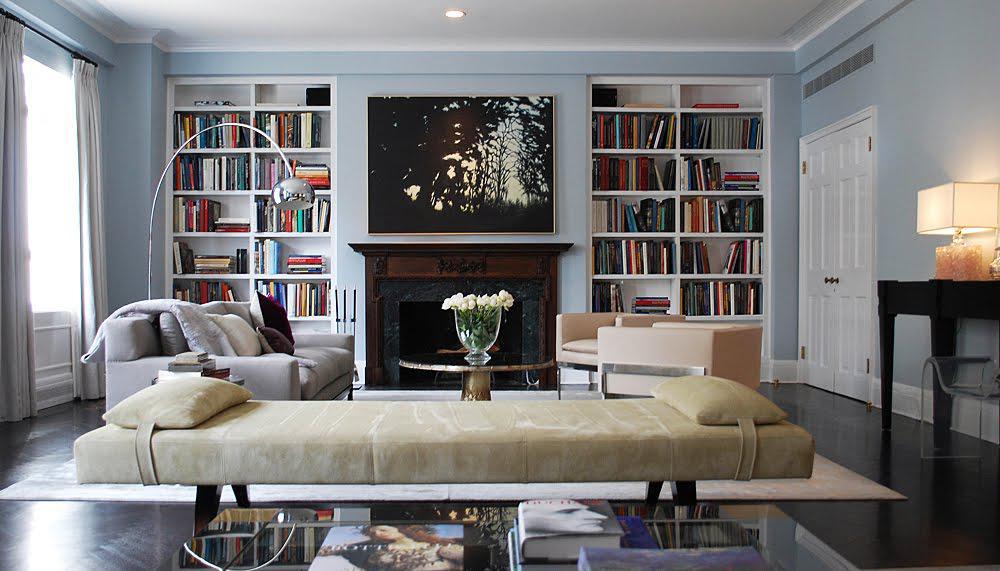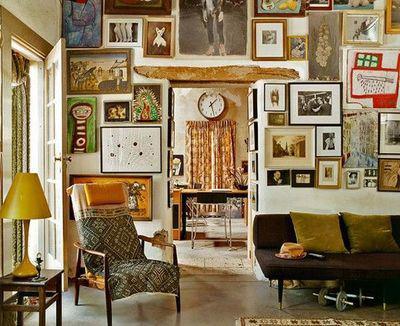The first image is the image on the left, the second image is the image on the right. For the images shown, is this caption "In one image, floor to ceiling bookshelves are on both sides of a central fireplace with decor filling the space above." true? Answer yes or no. Yes. The first image is the image on the left, the second image is the image on the right. For the images displayed, is the sentence "A room includes a beige sofa near a fireplace flanked by white built-in bookshelves, with something rectangular over the fireplace." factually correct? Answer yes or no. Yes. 